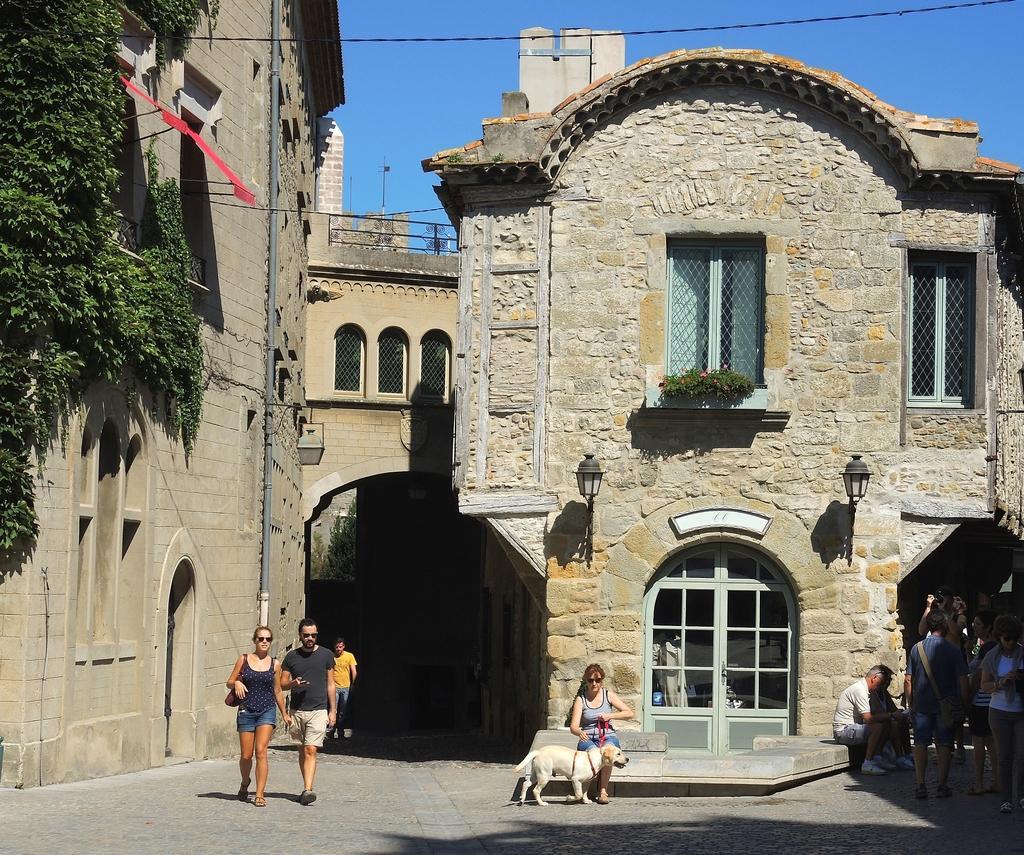How would you summarize this image in a sentence or two? In this picture I can see group of people standing and there is a woman sitting and holding the belt of a dog. There are buildings, plants, lights, and in the background there is the sky. 